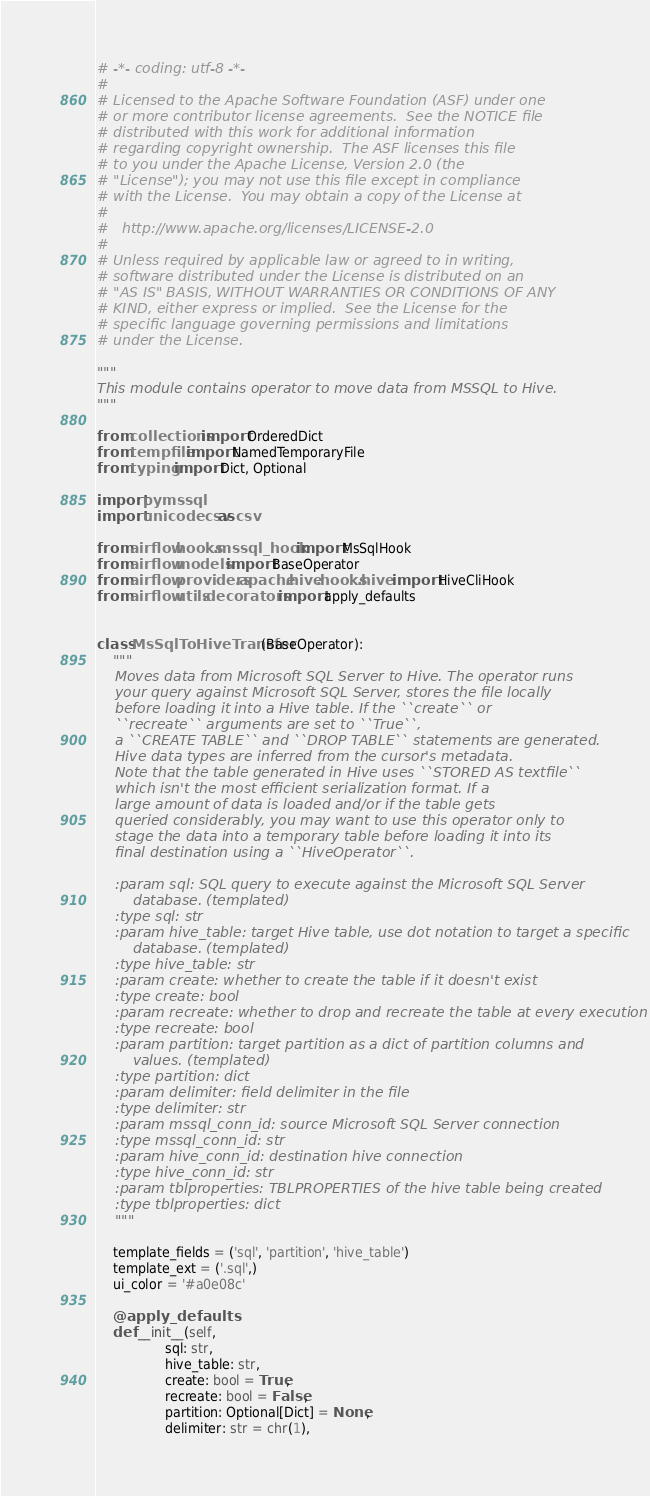Convert code to text. <code><loc_0><loc_0><loc_500><loc_500><_Python_># -*- coding: utf-8 -*-
#
# Licensed to the Apache Software Foundation (ASF) under one
# or more contributor license agreements.  See the NOTICE file
# distributed with this work for additional information
# regarding copyright ownership.  The ASF licenses this file
# to you under the Apache License, Version 2.0 (the
# "License"); you may not use this file except in compliance
# with the License.  You may obtain a copy of the License at
#
#   http://www.apache.org/licenses/LICENSE-2.0
#
# Unless required by applicable law or agreed to in writing,
# software distributed under the License is distributed on an
# "AS IS" BASIS, WITHOUT WARRANTIES OR CONDITIONS OF ANY
# KIND, either express or implied.  See the License for the
# specific language governing permissions and limitations
# under the License.

"""
This module contains operator to move data from MSSQL to Hive.
"""

from collections import OrderedDict
from tempfile import NamedTemporaryFile
from typing import Dict, Optional

import pymssql
import unicodecsv as csv

from airflow.hooks.mssql_hook import MsSqlHook
from airflow.models import BaseOperator
from airflow.providers.apache.hive.hooks.hive import HiveCliHook
from airflow.utils.decorators import apply_defaults


class MsSqlToHiveTransfer(BaseOperator):
    """
    Moves data from Microsoft SQL Server to Hive. The operator runs
    your query against Microsoft SQL Server, stores the file locally
    before loading it into a Hive table. If the ``create`` or
    ``recreate`` arguments are set to ``True``,
    a ``CREATE TABLE`` and ``DROP TABLE`` statements are generated.
    Hive data types are inferred from the cursor's metadata.
    Note that the table generated in Hive uses ``STORED AS textfile``
    which isn't the most efficient serialization format. If a
    large amount of data is loaded and/or if the table gets
    queried considerably, you may want to use this operator only to
    stage the data into a temporary table before loading it into its
    final destination using a ``HiveOperator``.

    :param sql: SQL query to execute against the Microsoft SQL Server
        database. (templated)
    :type sql: str
    :param hive_table: target Hive table, use dot notation to target a specific
        database. (templated)
    :type hive_table: str
    :param create: whether to create the table if it doesn't exist
    :type create: bool
    :param recreate: whether to drop and recreate the table at every execution
    :type recreate: bool
    :param partition: target partition as a dict of partition columns and
        values. (templated)
    :type partition: dict
    :param delimiter: field delimiter in the file
    :type delimiter: str
    :param mssql_conn_id: source Microsoft SQL Server connection
    :type mssql_conn_id: str
    :param hive_conn_id: destination hive connection
    :type hive_conn_id: str
    :param tblproperties: TBLPROPERTIES of the hive table being created
    :type tblproperties: dict
    """

    template_fields = ('sql', 'partition', 'hive_table')
    template_ext = ('.sql',)
    ui_color = '#a0e08c'

    @apply_defaults
    def __init__(self,
                 sql: str,
                 hive_table: str,
                 create: bool = True,
                 recreate: bool = False,
                 partition: Optional[Dict] = None,
                 delimiter: str = chr(1),</code> 